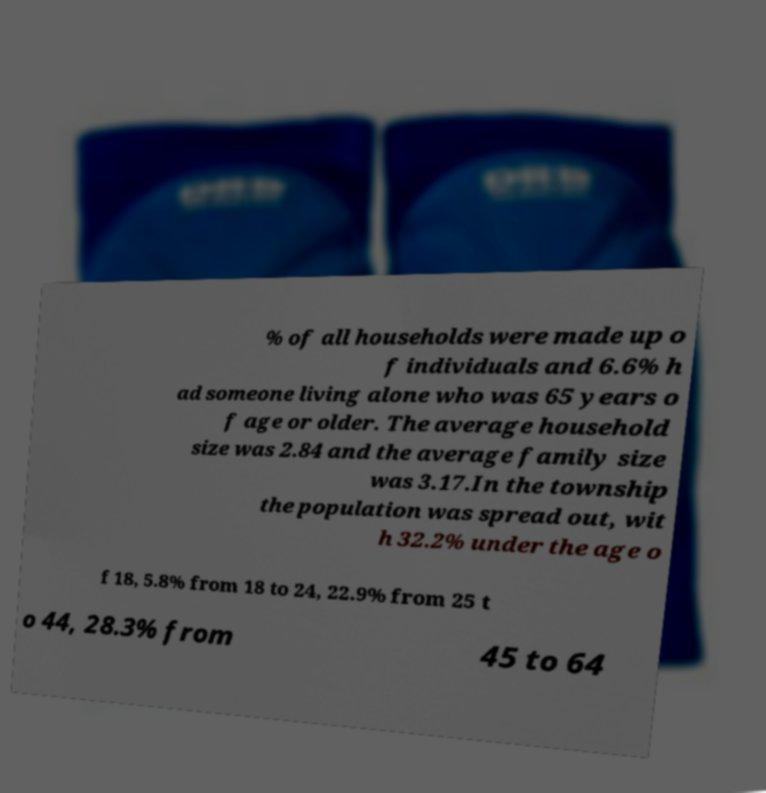There's text embedded in this image that I need extracted. Can you transcribe it verbatim? % of all households were made up o f individuals and 6.6% h ad someone living alone who was 65 years o f age or older. The average household size was 2.84 and the average family size was 3.17.In the township the population was spread out, wit h 32.2% under the age o f 18, 5.8% from 18 to 24, 22.9% from 25 t o 44, 28.3% from 45 to 64 